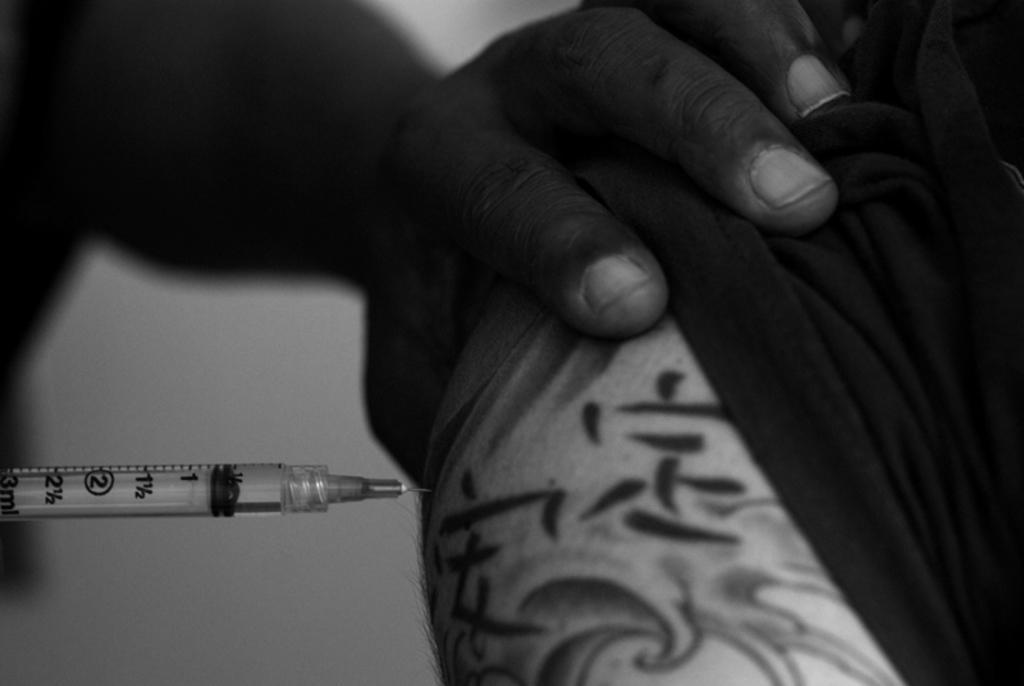Please provide a concise description of this image. In the foreground of this picture we can see a person seems to be holding an injection and injection the liquid into the vein of another persons and we can see some other objects. 